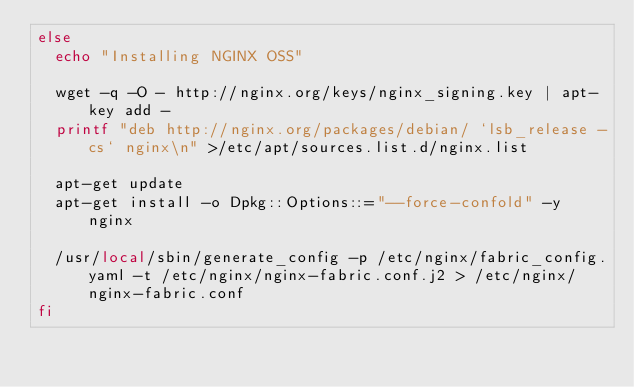Convert code to text. <code><loc_0><loc_0><loc_500><loc_500><_Bash_>else
  echo "Installing NGINX OSS"

  wget -q -O - http://nginx.org/keys/nginx_signing.key | apt-key add -
  printf "deb http://nginx.org/packages/debian/ `lsb_release -cs` nginx\n" >/etc/apt/sources.list.d/nginx.list

  apt-get update
  apt-get install -o Dpkg::Options::="--force-confold" -y nginx

  /usr/local/sbin/generate_config -p /etc/nginx/fabric_config.yaml -t /etc/nginx/nginx-fabric.conf.j2 > /etc/nginx/nginx-fabric.conf
fi
</code> 